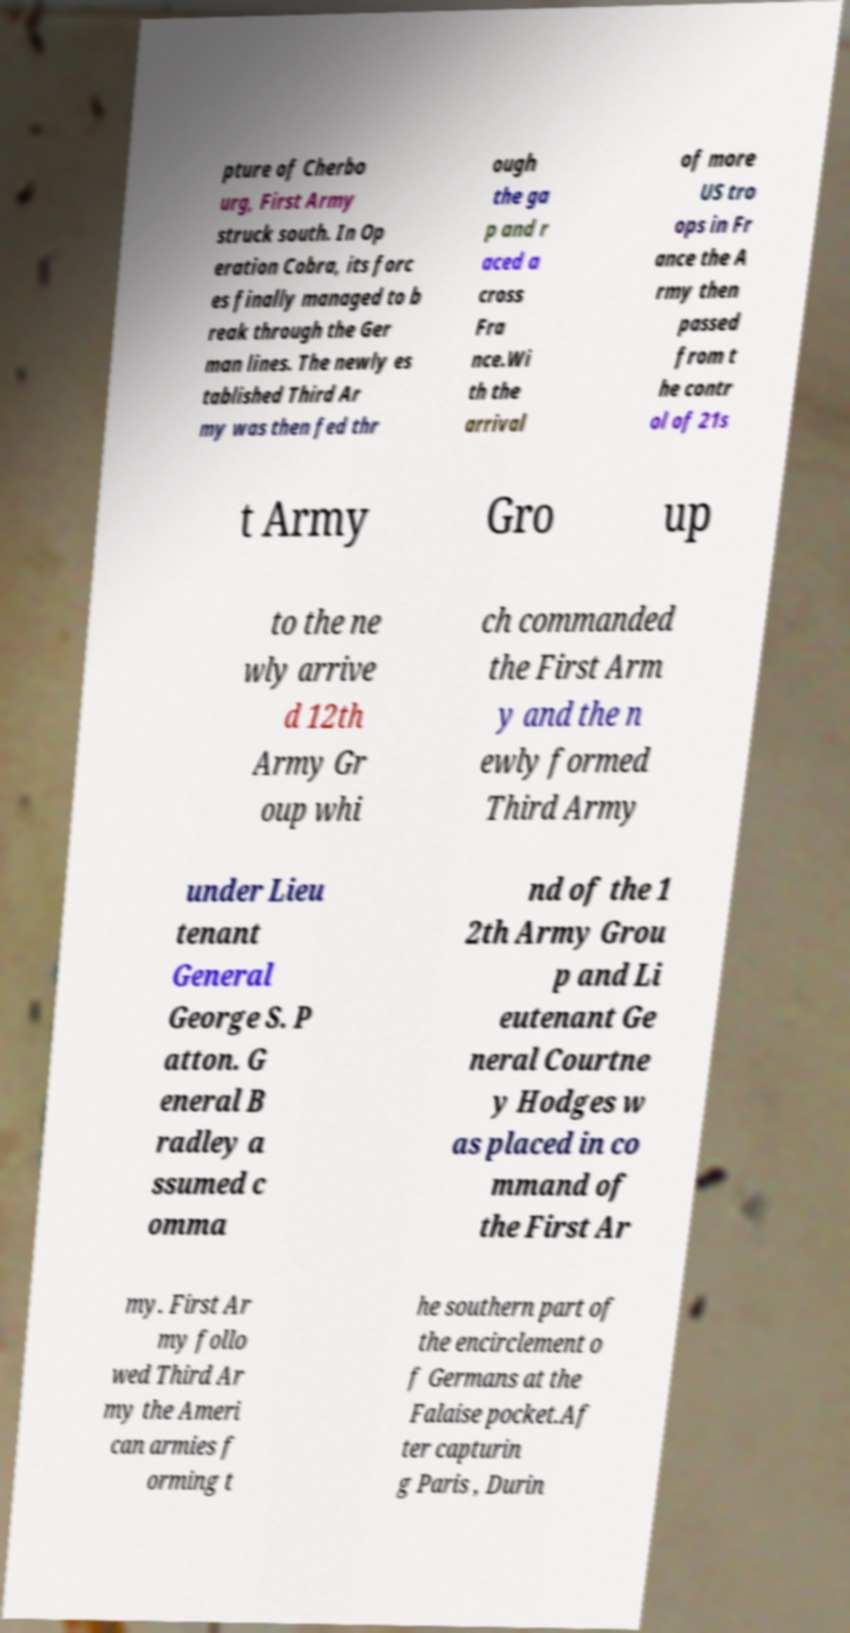I need the written content from this picture converted into text. Can you do that? pture of Cherbo urg, First Army struck south. In Op eration Cobra, its forc es finally managed to b reak through the Ger man lines. The newly es tablished Third Ar my was then fed thr ough the ga p and r aced a cross Fra nce.Wi th the arrival of more US tro ops in Fr ance the A rmy then passed from t he contr ol of 21s t Army Gro up to the ne wly arrive d 12th Army Gr oup whi ch commanded the First Arm y and the n ewly formed Third Army under Lieu tenant General George S. P atton. G eneral B radley a ssumed c omma nd of the 1 2th Army Grou p and Li eutenant Ge neral Courtne y Hodges w as placed in co mmand of the First Ar my. First Ar my follo wed Third Ar my the Ameri can armies f orming t he southern part of the encirclement o f Germans at the Falaise pocket.Af ter capturin g Paris , Durin 